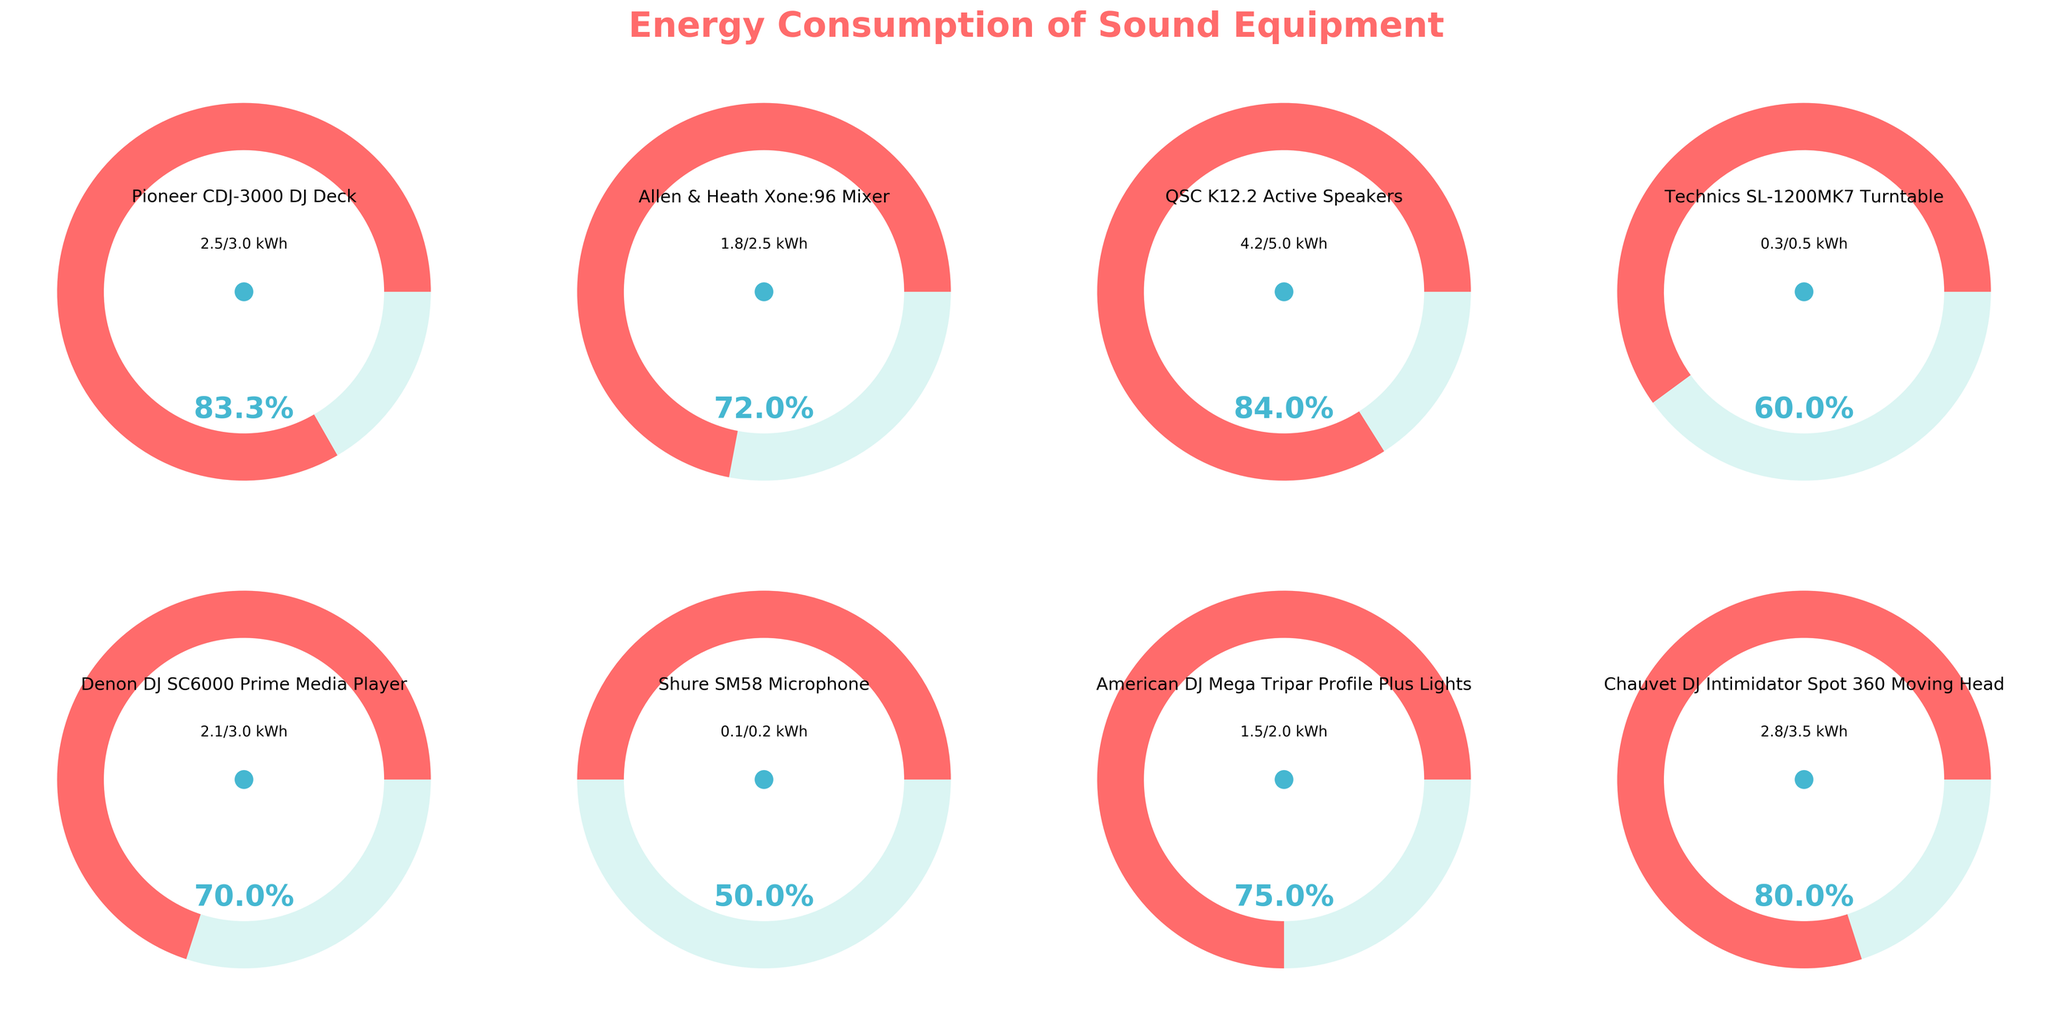What is the energy consumption percentage of the Pioneer CDJ-3000 DJ Deck? The energy consumption is shown as a gauge with a red fill. The gauge indicates the percentage of energy consumption relative to its maximum capacity. For the Pioneer CDJ-3000 DJ Deck, this percentage is labeled directly in the plot
Answer: 83.3% Which piece of equipment has the highest energy consumption percentage? By comparing the gauges, we see that the QSC K12.2 Active Speakers have the highest percentage fill within the gauge, indicating they consume the most energy relative to their maximum capacity
Answer: QSC K12.2 Active Speakers How many pieces of equipment have an energy consumption percentage of 70% or more? Inspect each gauge and check the percentage labels. The Pioneer CDJ-3000 DJ Deck (83.3%), QSC K12.2 Active Speakers (84%), Denon DJ SC6000 Prime Media Player (70%), and Chauvet DJ Intimidator Spot 360 Moving Head (80%) all exceed 70%
Answer: 4 What is the average energy consumption percentage across all equipment? Add each percentage (83.3%, 72%, 84%, 60%, 70%, 50%, 75%, 80%) and divide by the number of equipment (8). The sum is 574.3, so 574.3/8 = 71.79%
Answer: 71.8% Which equipment has the lowest energy consumption percentage relative to its maximum capacity? By comparing the gauges, the Shure SM58 Microphone has the lowest percentage, which is labeled directly as 50% in the plot
Answer: Shure SM58 Microphone What is the total energy consumption in kWh for all equipment combined? Add up all the energy consumption values from the table: 2.5 + 1.8 + 4.2 + 0.3 + 2.1 + 0.1 + 1.5 + 2.8 = 15.3 kWh
Answer: 15.3 kWh By what percentage does the Pioneer CDJ-3000 DJ Deck exceed the energy consumption of the Technics SL-1200MK7 Turntable? The Pioneer CDJ-3000 consumes 2.5 kWh and the Technics SL-1200MK7 consumes 0.3 kWh. The difference is 2.2 kWh. The percentage is (2.2 / 0.3) * 100 = 733.3%
Answer: 733.3% How does the energy consumption of the Allen & Heath Xone:96 Mixer compare to the Denon DJ SC6000 Prime Media Player? The Allen & Heath Xone:96 Mixer has an energy consumption of 1.8 kWh, while the Denon DJ SC6000 Prime Media Player consumes 2.1 kWh. The Denon DJ SC6000 Prime Media Player consumes 0.3 kWh more than the Allen & Heath Xone:96 Mixer
Answer: Denon DJ SC6000 Prime Media Player consumes 0.3 kWh more Which equipment consumes exactly 1.5 kWh of energy? From the labeled consumption values on each gauge, the American DJ Mega Tripar Profile Plus Lights consumes exactly 1.5 kWh
Answer: American DJ Mega Tripar Profile Plus Lights 